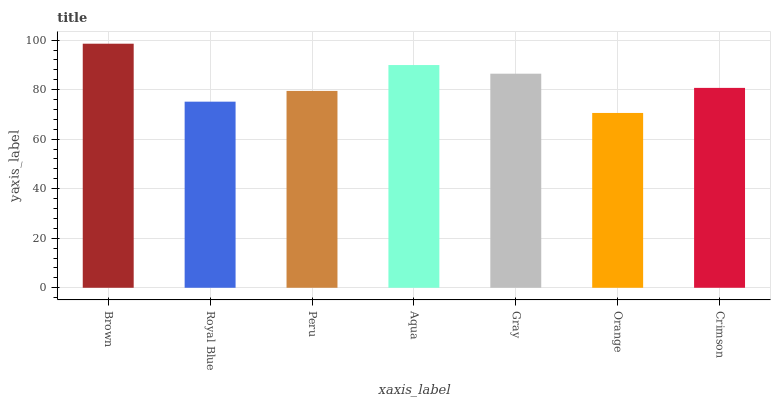Is Orange the minimum?
Answer yes or no. Yes. Is Brown the maximum?
Answer yes or no. Yes. Is Royal Blue the minimum?
Answer yes or no. No. Is Royal Blue the maximum?
Answer yes or no. No. Is Brown greater than Royal Blue?
Answer yes or no. Yes. Is Royal Blue less than Brown?
Answer yes or no. Yes. Is Royal Blue greater than Brown?
Answer yes or no. No. Is Brown less than Royal Blue?
Answer yes or no. No. Is Crimson the high median?
Answer yes or no. Yes. Is Crimson the low median?
Answer yes or no. Yes. Is Brown the high median?
Answer yes or no. No. Is Peru the low median?
Answer yes or no. No. 